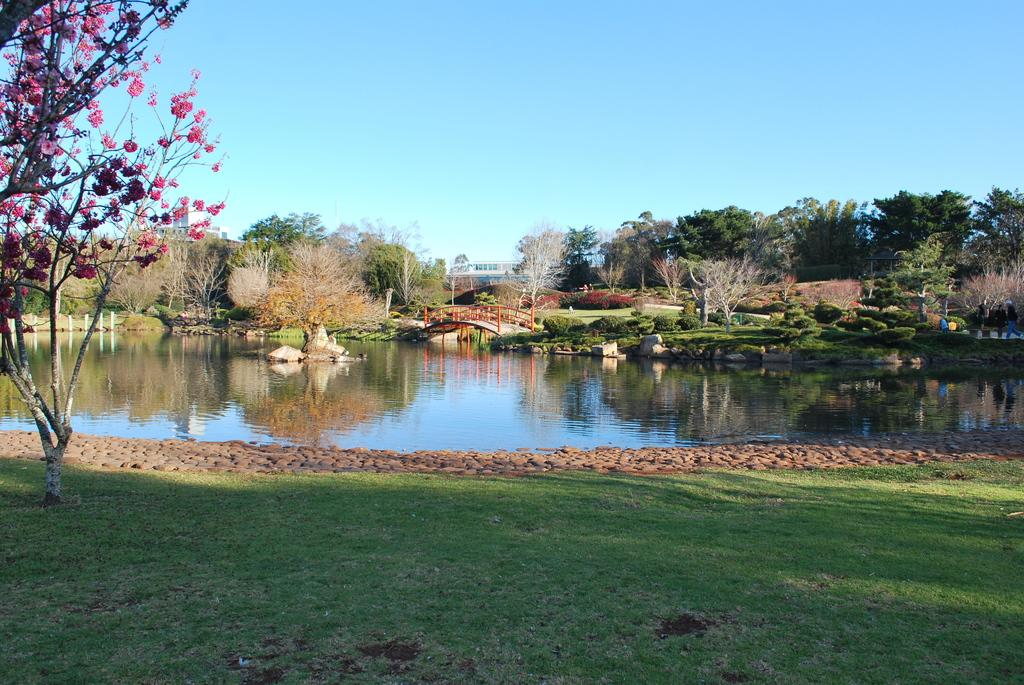What type of terrain is at the bottom of the image? There is grass at the bottom of the image. What can be seen in the distance in the image? There are trees and water visible in the background of the image. What structure is present in the background of the image? There is a bridge in the background of the image. What part of the natural environment is visible in the image? The sky is visible in the background of the image. Are there any giants visible in the image? No, there are no giants present in the image. Is there a gun visible in the image? No, there is no gun present in the image. 